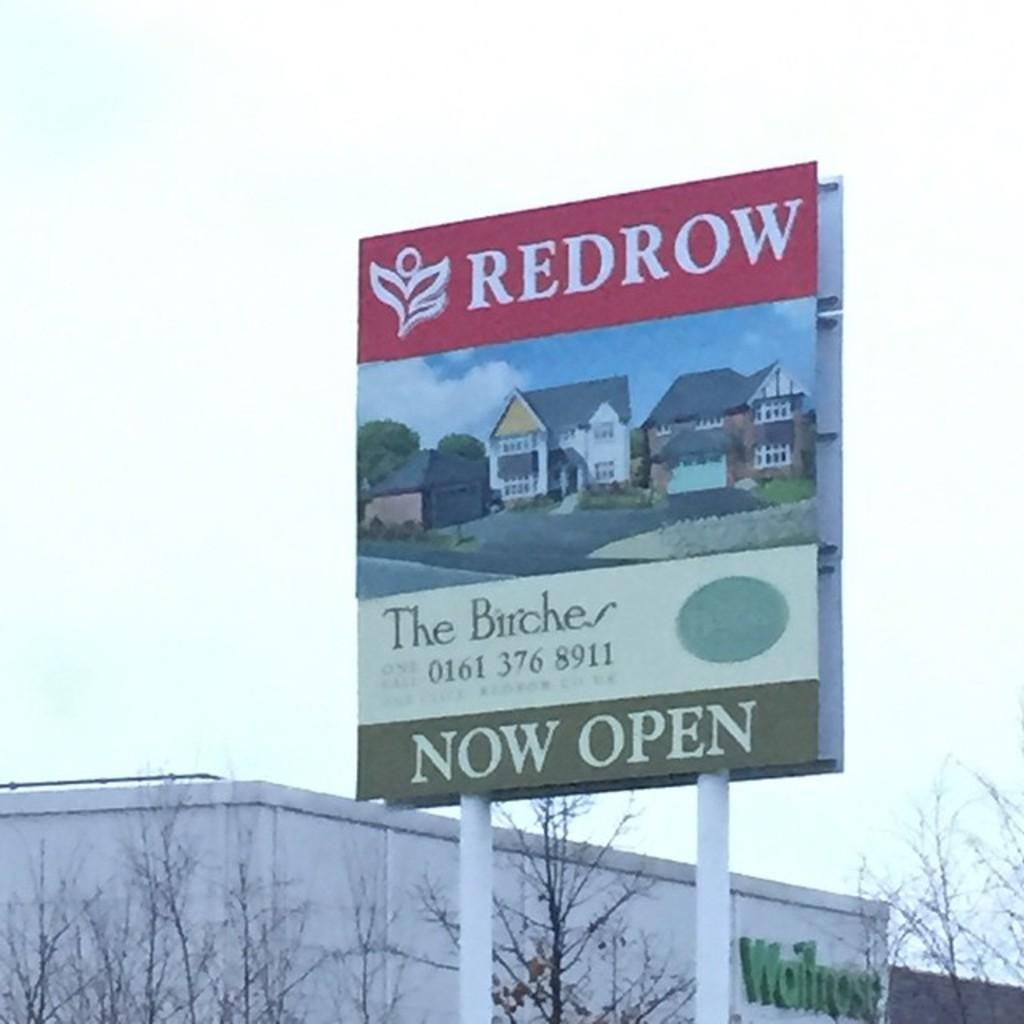<image>
Create a compact narrative representing the image presented. A sign states that The Birches are now open. 